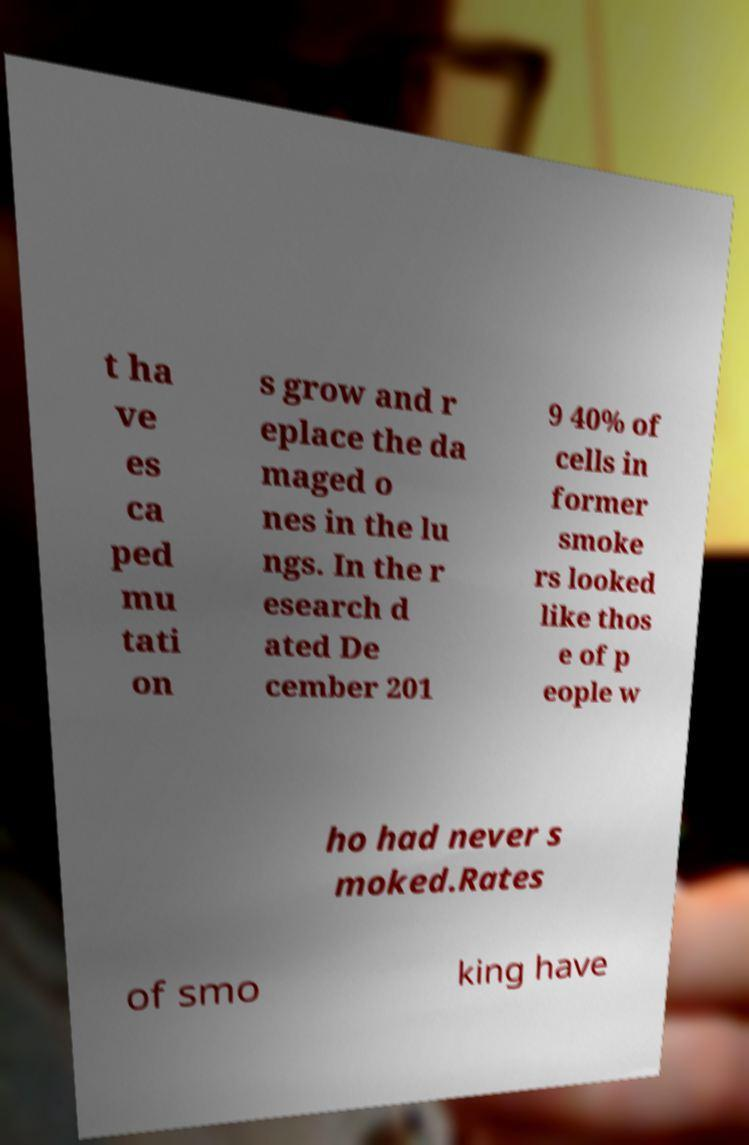For documentation purposes, I need the text within this image transcribed. Could you provide that? t ha ve es ca ped mu tati on s grow and r eplace the da maged o nes in the lu ngs. In the r esearch d ated De cember 201 9 40% of cells in former smoke rs looked like thos e of p eople w ho had never s moked.Rates of smo king have 